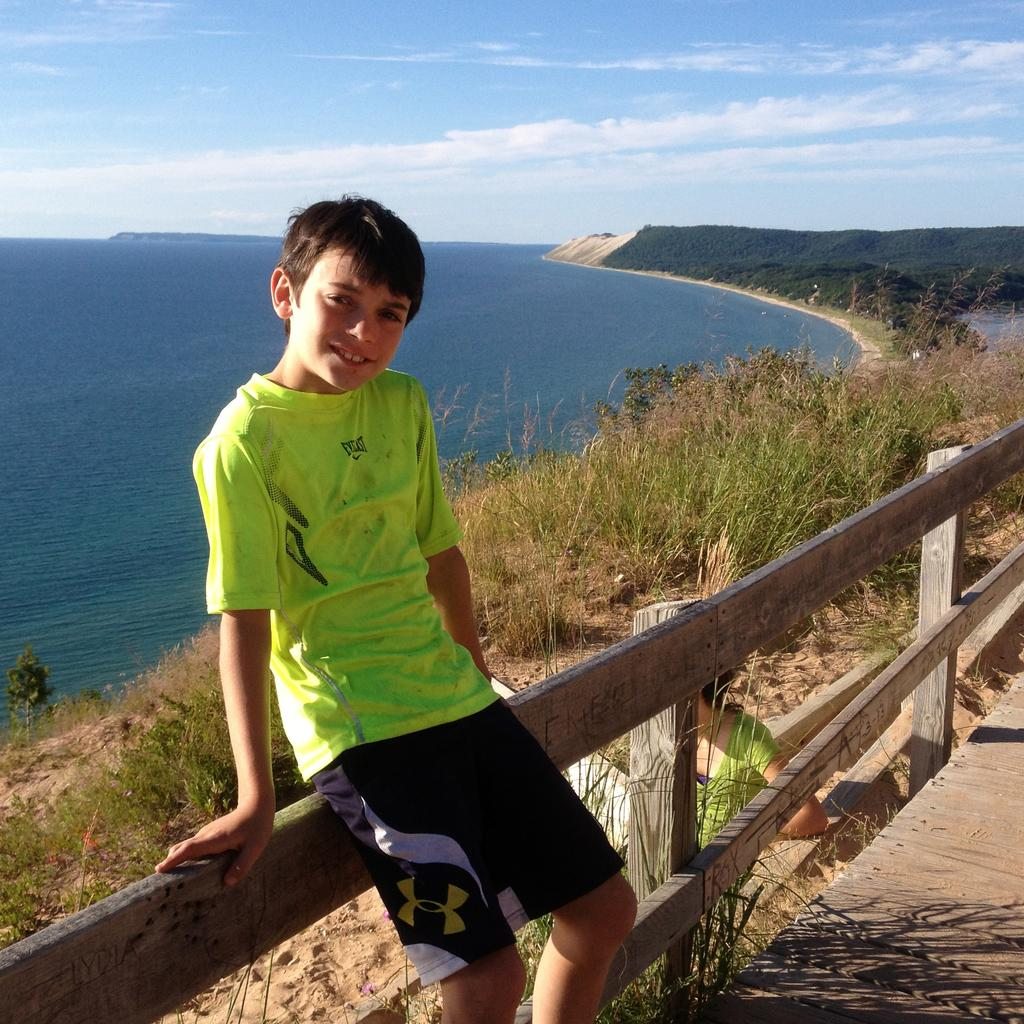<image>
Summarize the visual content of the image. A boy poses at fence overlooking the ocean wearing an Evelast t-shirt. 